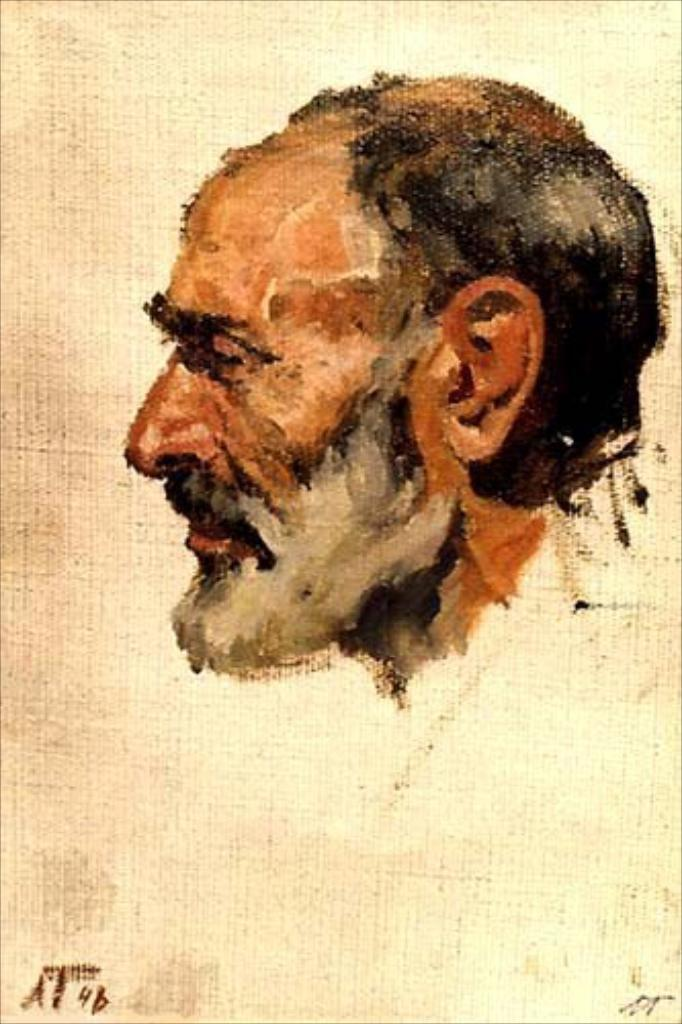What is the main subject of the image? There is an art piece in the image. What is depicted in the art piece? The art piece contains a person's head. What type of tin can be seen in the background of the image? There is no tin present in the image. What is the shape of the person's head in the art piece? The provided facts do not specify the shape of the person's head in the art piece. 